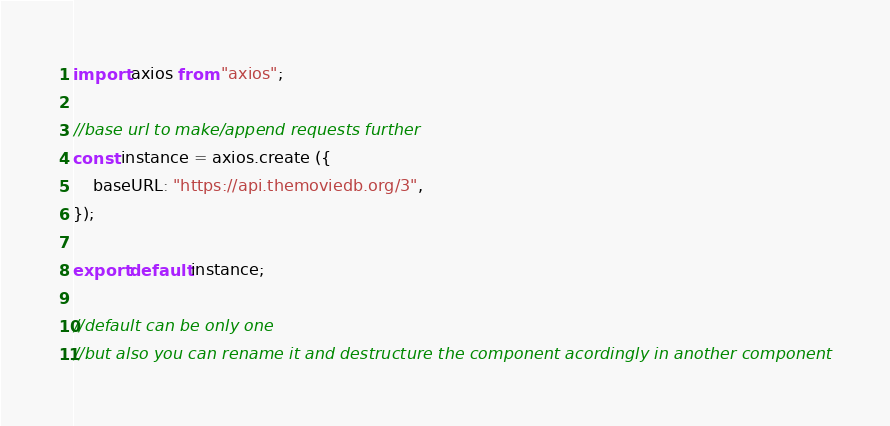<code> <loc_0><loc_0><loc_500><loc_500><_JavaScript_>import axios from "axios";

//base url to make/append requests further
const instance = axios.create ({
    baseURL: "https://api.themoviedb.org/3",
});

export default instance;

//default can be only one
//but also you can rename it and destructure the component acordingly in another component</code> 